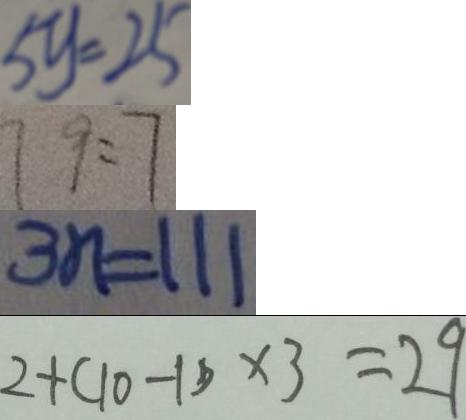Convert formula to latex. <formula><loc_0><loc_0><loc_500><loc_500>5 y = 2 5 
 7 9 = 7 
 3 n = 1 1 1 
 2 + ( 1 0 - 1 ) \times 3 = 2 9</formula> 